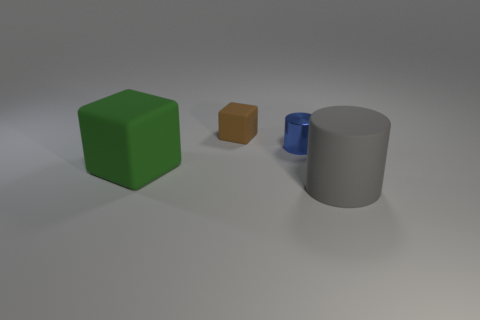Add 3 cyan matte things. How many objects exist? 7 Subtract all tiny yellow cylinders. Subtract all green things. How many objects are left? 3 Add 4 big matte things. How many big matte things are left? 6 Add 4 yellow objects. How many yellow objects exist? 4 Subtract 0 purple balls. How many objects are left? 4 